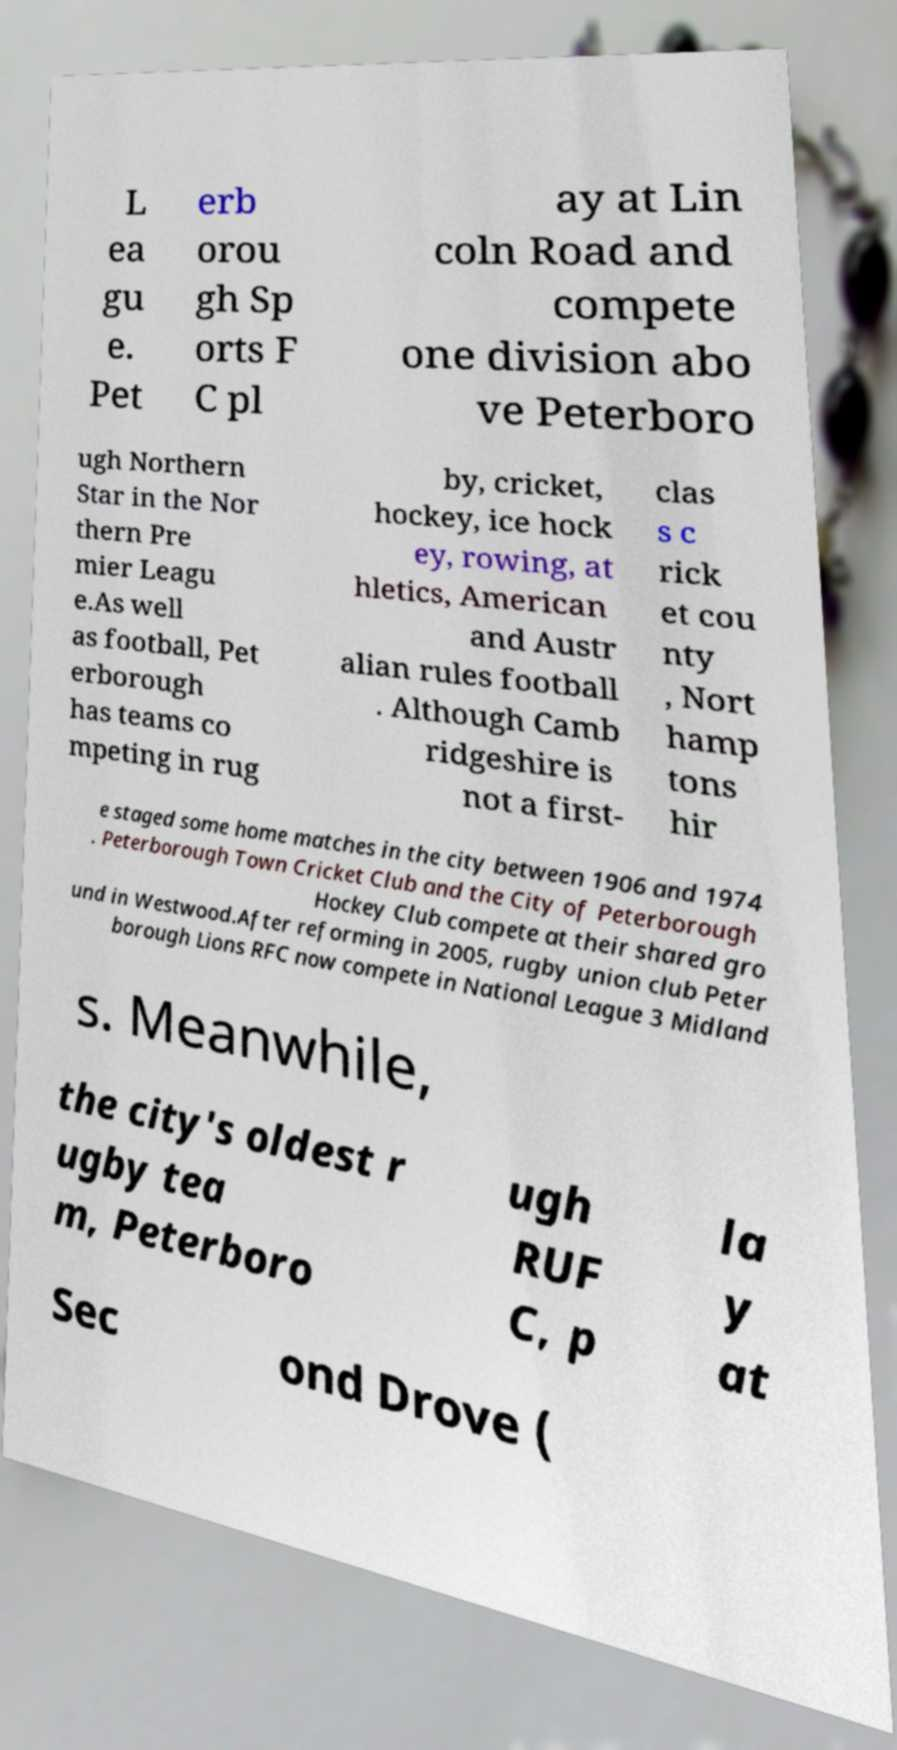Can you accurately transcribe the text from the provided image for me? L ea gu e. Pet erb orou gh Sp orts F C pl ay at Lin coln Road and compete one division abo ve Peterboro ugh Northern Star in the Nor thern Pre mier Leagu e.As well as football, Pet erborough has teams co mpeting in rug by, cricket, hockey, ice hock ey, rowing, at hletics, American and Austr alian rules football . Although Camb ridgeshire is not a first- clas s c rick et cou nty , Nort hamp tons hir e staged some home matches in the city between 1906 and 1974 . Peterborough Town Cricket Club and the City of Peterborough Hockey Club compete at their shared gro und in Westwood.After reforming in 2005, rugby union club Peter borough Lions RFC now compete in National League 3 Midland s. Meanwhile, the city's oldest r ugby tea m, Peterboro ugh RUF C, p la y at Sec ond Drove ( 